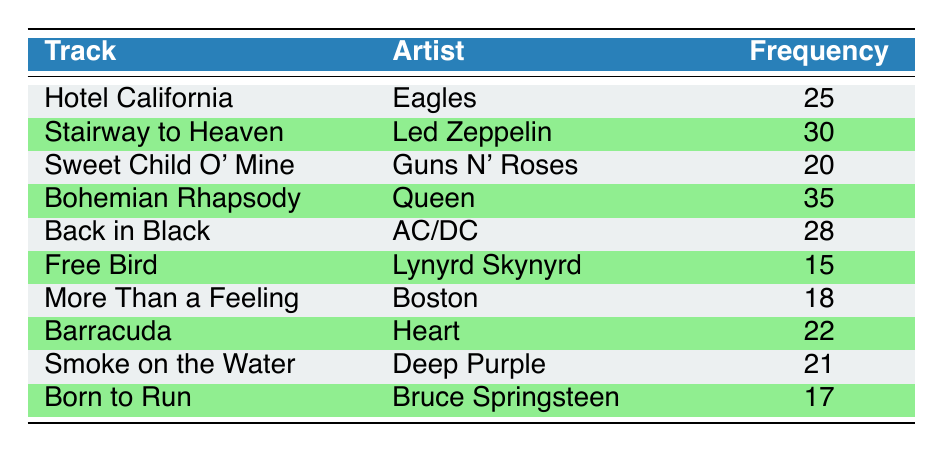What track has the highest frequency of plays? The highest frequency can be identified by comparing the frequency values in the table. "Bohemian Rhapsody" has the highest frequency with 35 plays.
Answer: Bohemian Rhapsody Which artist performed "Sweet Child O' Mine"? The table lists the track "Sweet Child O' Mine" alongside its corresponding artist, which is "Guns N' Roses".
Answer: Guns N' Roses What is the average frequency of plays for the tracks listed? To find the average frequency, sum the frequencies: 25 + 30 + 20 + 35 + 28 + 15 + 18 + 22 + 21 + 17 =  211. There are 10 tracks, so the average is 211/10 = 21.1.
Answer: 21.1 Is the frequency of "Back in Black" greater than the frequency of "Free Bird"? The frequency of "Back in Black" is 28 while the frequency of "Free Bird" is 15. Since 28 is greater than 15, the statement is true.
Answer: Yes How many tracks have a frequency of more than 20? By inspecting the frequencies listed in the table, the tracks with more than 20 plays are: "Hotel California", "Stairway to Heaven", "Bohemian Rhapsody", "Back in Black", "Barracuda", and "Smoke on the Water". This totals 6 tracks.
Answer: 6 Which track has the lowest frequency of plays? The lowest frequency can be determined by reviewing the frequency numbers in the table. "Free Bird" has the lowest frequency with 15 plays.
Answer: Free Bird What is the difference in frequency between "Stairway to Heaven" and "Born to Run"? "Stairway to Heaven" has a frequency of 30 and "Born to Run" has a frequency of 17. The difference is calculated by subtracting: 30 - 17 = 13.
Answer: 13 Are there more tracks by artists with frequencies less than 20 or more than 20? The artists with frequencies less than 20 are "Free Bird" (15), "More Than a Feeling" (18), and "Born to Run" (17), totaling 3 tracks. The artists with frequencies above 20 are "Hotel California" (25), "Stairway to Heaven" (30), "Bohemian Rhapsody" (35), "Back in Black" (28), "Barracuda" (22), and "Smoke on the Water" (21), totaling 6 tracks. Since 6 is greater than 3, the tracks with frequencies above 20 are more.
Answer: More than 20 What is the total frequency of tracks by Queen and AC/DC? The frequencies for "Bohemian Rhapsody" by Queen is 35 and "Back in Black" by AC/DC is 28. Adding these together gives: 35 + 28 = 63.
Answer: 63 